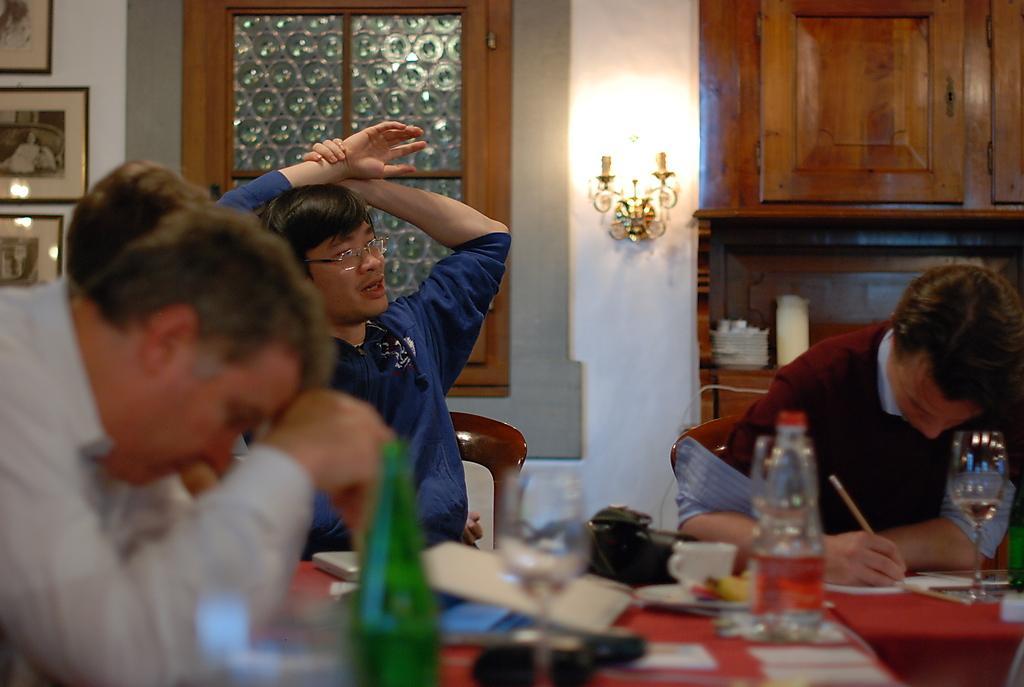In one or two sentences, can you explain what this image depicts? In this picture there are some men sitting. To the right corner there is a man with maroon color t-shirt is sitting and writing something on the paper. Beside him there is another man with blue jacket is sitting. To the left corner there is another man sitting. On the table there are some objects like cup, bottle papers. In the background there is a window. To the left side wall there are three frames. Light and a cupboard. 